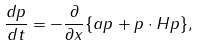<formula> <loc_0><loc_0><loc_500><loc_500>\frac { d p } { d t } = - \frac { \partial } { \partial x } \{ a p + p \cdot H p \} ,</formula> 